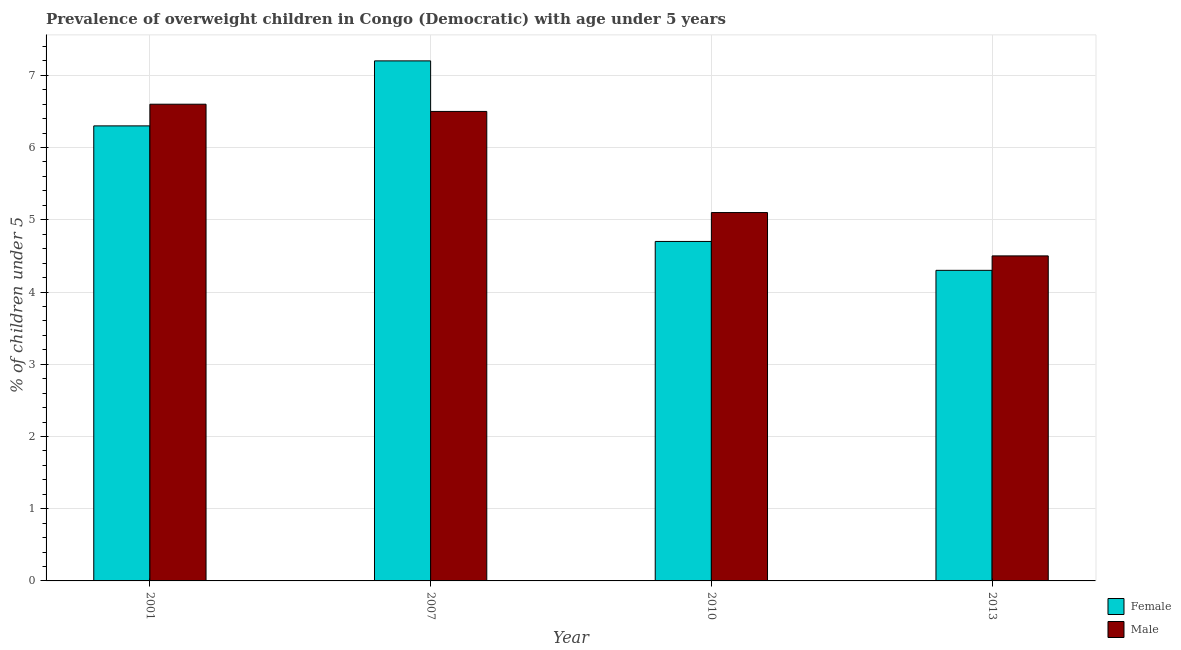How many groups of bars are there?
Your response must be concise. 4. What is the label of the 4th group of bars from the left?
Ensure brevity in your answer.  2013. What is the percentage of obese female children in 2001?
Give a very brief answer. 6.3. Across all years, what is the maximum percentage of obese female children?
Your response must be concise. 7.2. Across all years, what is the minimum percentage of obese female children?
Your answer should be very brief. 4.3. In which year was the percentage of obese female children maximum?
Make the answer very short. 2007. In which year was the percentage of obese male children minimum?
Provide a short and direct response. 2013. What is the total percentage of obese male children in the graph?
Ensure brevity in your answer.  22.7. What is the difference between the percentage of obese male children in 2007 and that in 2010?
Your response must be concise. 1.4. What is the difference between the percentage of obese female children in 2013 and the percentage of obese male children in 2007?
Provide a short and direct response. -2.9. What is the average percentage of obese male children per year?
Your response must be concise. 5.67. In how many years, is the percentage of obese male children greater than 1.8 %?
Your answer should be compact. 4. What is the ratio of the percentage of obese female children in 2001 to that in 2010?
Give a very brief answer. 1.34. What is the difference between the highest and the second highest percentage of obese female children?
Your answer should be very brief. 0.9. What is the difference between the highest and the lowest percentage of obese male children?
Provide a short and direct response. 2.1. In how many years, is the percentage of obese male children greater than the average percentage of obese male children taken over all years?
Make the answer very short. 2. What does the 1st bar from the left in 2010 represents?
Provide a succinct answer. Female. Are all the bars in the graph horizontal?
Provide a succinct answer. No. How many years are there in the graph?
Provide a short and direct response. 4. Are the values on the major ticks of Y-axis written in scientific E-notation?
Offer a very short reply. No. Does the graph contain grids?
Offer a terse response. Yes. Where does the legend appear in the graph?
Keep it short and to the point. Bottom right. How many legend labels are there?
Your answer should be very brief. 2. What is the title of the graph?
Offer a terse response. Prevalence of overweight children in Congo (Democratic) with age under 5 years. What is the label or title of the X-axis?
Your answer should be very brief. Year. What is the label or title of the Y-axis?
Your response must be concise.  % of children under 5. What is the  % of children under 5 in Female in 2001?
Offer a terse response. 6.3. What is the  % of children under 5 of Male in 2001?
Offer a very short reply. 6.6. What is the  % of children under 5 in Female in 2007?
Provide a short and direct response. 7.2. What is the  % of children under 5 in Female in 2010?
Provide a succinct answer. 4.7. What is the  % of children under 5 in Male in 2010?
Provide a succinct answer. 5.1. What is the  % of children under 5 of Female in 2013?
Give a very brief answer. 4.3. What is the  % of children under 5 of Male in 2013?
Offer a very short reply. 4.5. Across all years, what is the maximum  % of children under 5 of Female?
Your answer should be compact. 7.2. Across all years, what is the maximum  % of children under 5 in Male?
Ensure brevity in your answer.  6.6. Across all years, what is the minimum  % of children under 5 of Female?
Make the answer very short. 4.3. What is the total  % of children under 5 of Female in the graph?
Your response must be concise. 22.5. What is the total  % of children under 5 of Male in the graph?
Provide a succinct answer. 22.7. What is the difference between the  % of children under 5 in Male in 2001 and that in 2007?
Make the answer very short. 0.1. What is the difference between the  % of children under 5 in Male in 2001 and that in 2010?
Your answer should be compact. 1.5. What is the difference between the  % of children under 5 of Female in 2001 and that in 2013?
Give a very brief answer. 2. What is the difference between the  % of children under 5 in Male in 2001 and that in 2013?
Provide a short and direct response. 2.1. What is the difference between the  % of children under 5 of Female in 2007 and that in 2010?
Your answer should be compact. 2.5. What is the difference between the  % of children under 5 in Male in 2007 and that in 2010?
Offer a very short reply. 1.4. What is the difference between the  % of children under 5 in Female in 2010 and that in 2013?
Your answer should be very brief. 0.4. What is the difference between the  % of children under 5 in Male in 2010 and that in 2013?
Offer a terse response. 0.6. What is the difference between the  % of children under 5 of Female in 2007 and the  % of children under 5 of Male in 2010?
Offer a terse response. 2.1. What is the difference between the  % of children under 5 in Female in 2007 and the  % of children under 5 in Male in 2013?
Provide a short and direct response. 2.7. What is the difference between the  % of children under 5 in Female in 2010 and the  % of children under 5 in Male in 2013?
Provide a short and direct response. 0.2. What is the average  % of children under 5 in Female per year?
Provide a short and direct response. 5.62. What is the average  % of children under 5 in Male per year?
Offer a terse response. 5.67. In the year 2001, what is the difference between the  % of children under 5 of Female and  % of children under 5 of Male?
Your answer should be compact. -0.3. In the year 2007, what is the difference between the  % of children under 5 in Female and  % of children under 5 in Male?
Provide a succinct answer. 0.7. In the year 2010, what is the difference between the  % of children under 5 in Female and  % of children under 5 in Male?
Provide a short and direct response. -0.4. In the year 2013, what is the difference between the  % of children under 5 in Female and  % of children under 5 in Male?
Offer a very short reply. -0.2. What is the ratio of the  % of children under 5 in Male in 2001 to that in 2007?
Ensure brevity in your answer.  1.02. What is the ratio of the  % of children under 5 in Female in 2001 to that in 2010?
Provide a succinct answer. 1.34. What is the ratio of the  % of children under 5 in Male in 2001 to that in 2010?
Your answer should be compact. 1.29. What is the ratio of the  % of children under 5 in Female in 2001 to that in 2013?
Your response must be concise. 1.47. What is the ratio of the  % of children under 5 of Male in 2001 to that in 2013?
Offer a terse response. 1.47. What is the ratio of the  % of children under 5 of Female in 2007 to that in 2010?
Make the answer very short. 1.53. What is the ratio of the  % of children under 5 of Male in 2007 to that in 2010?
Your answer should be very brief. 1.27. What is the ratio of the  % of children under 5 of Female in 2007 to that in 2013?
Provide a succinct answer. 1.67. What is the ratio of the  % of children under 5 of Male in 2007 to that in 2013?
Your response must be concise. 1.44. What is the ratio of the  % of children under 5 in Female in 2010 to that in 2013?
Ensure brevity in your answer.  1.09. What is the ratio of the  % of children under 5 of Male in 2010 to that in 2013?
Keep it short and to the point. 1.13. What is the difference between the highest and the lowest  % of children under 5 in Female?
Your answer should be compact. 2.9. What is the difference between the highest and the lowest  % of children under 5 of Male?
Offer a terse response. 2.1. 